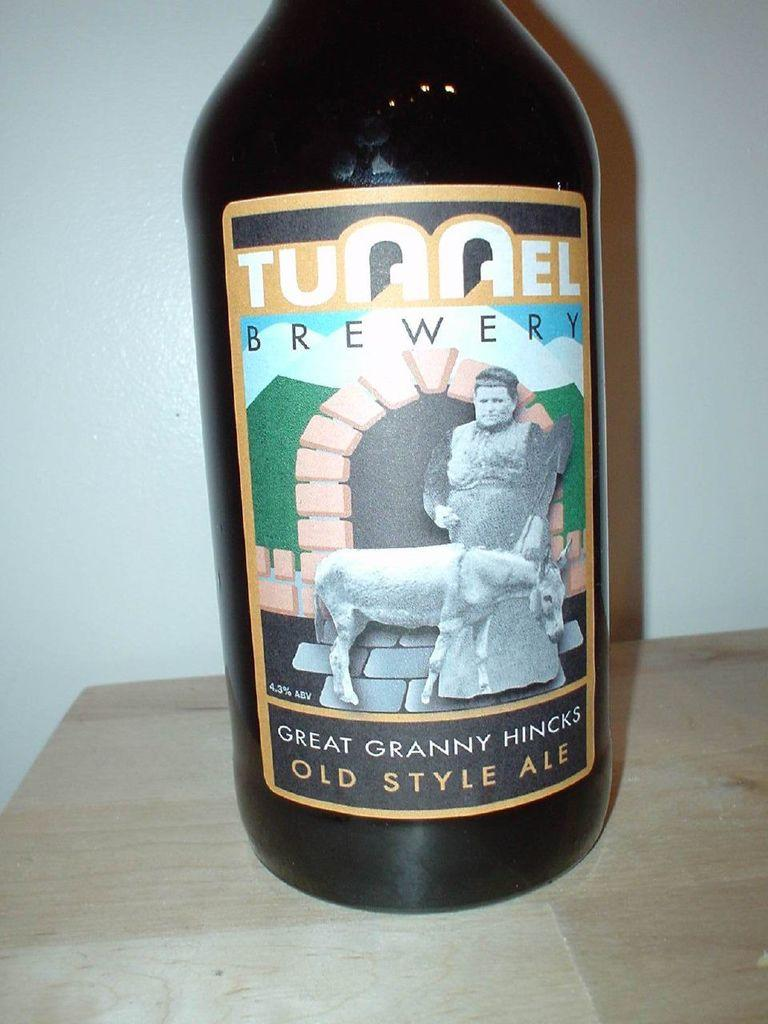<image>
Give a short and clear explanation of the subsequent image. A black bottle of Tunnel Brewery old style ale with a picture of a lady and a horse on it. 